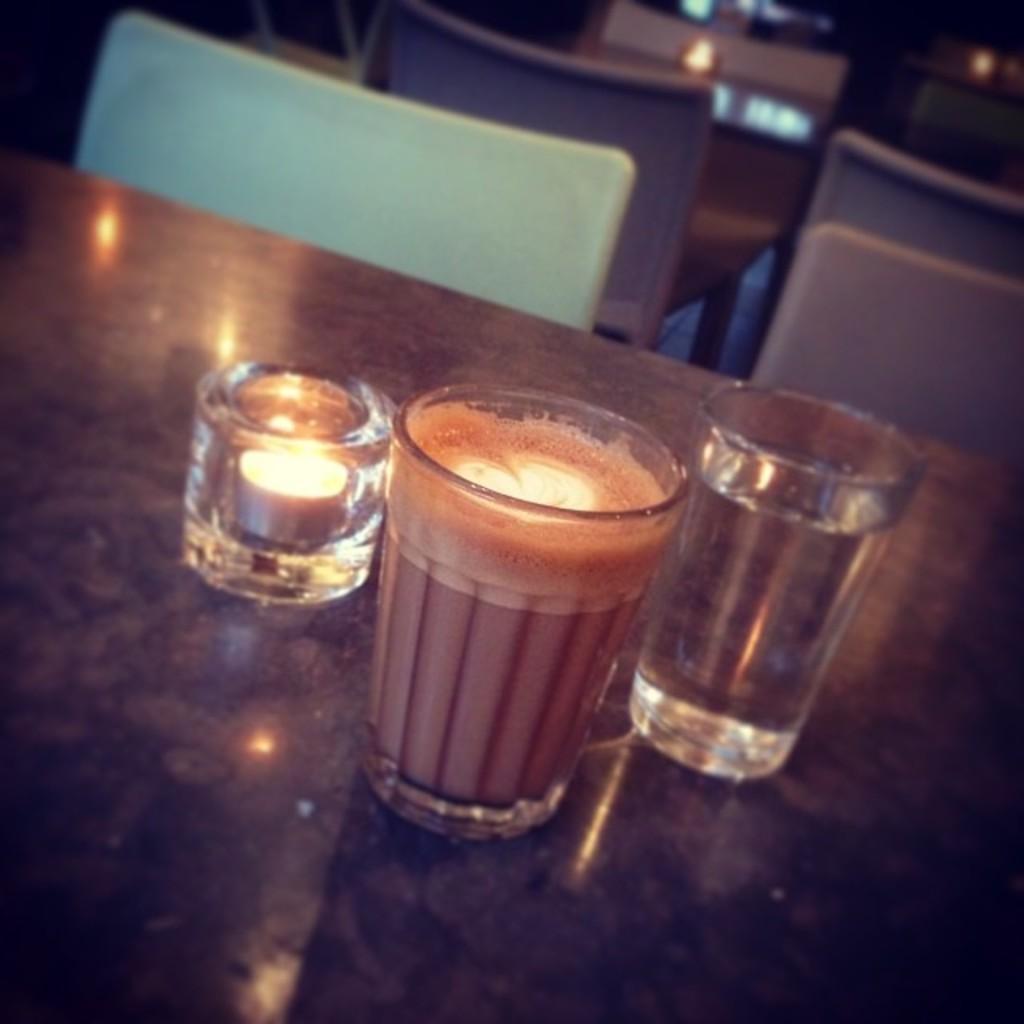In one or two sentences, can you explain what this image depicts? As we can see in the image there are tables and chairs. On table there are glasses. 